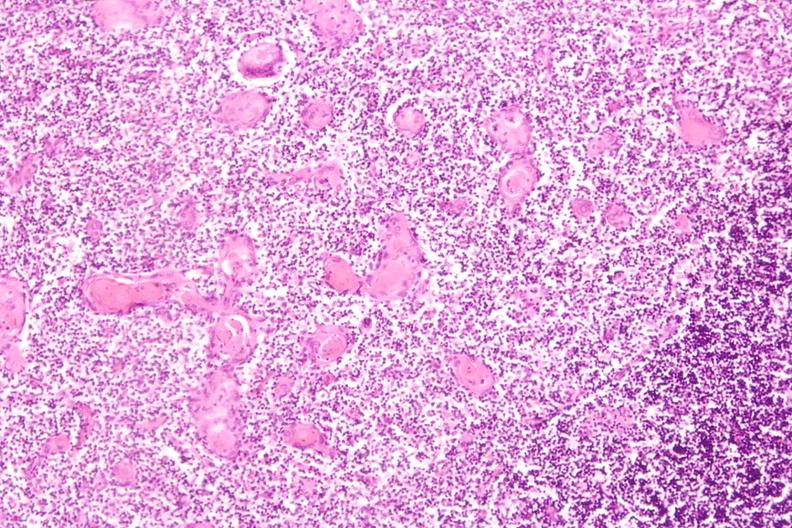does this image show thymus?
Answer the question using a single word or phrase. Yes 